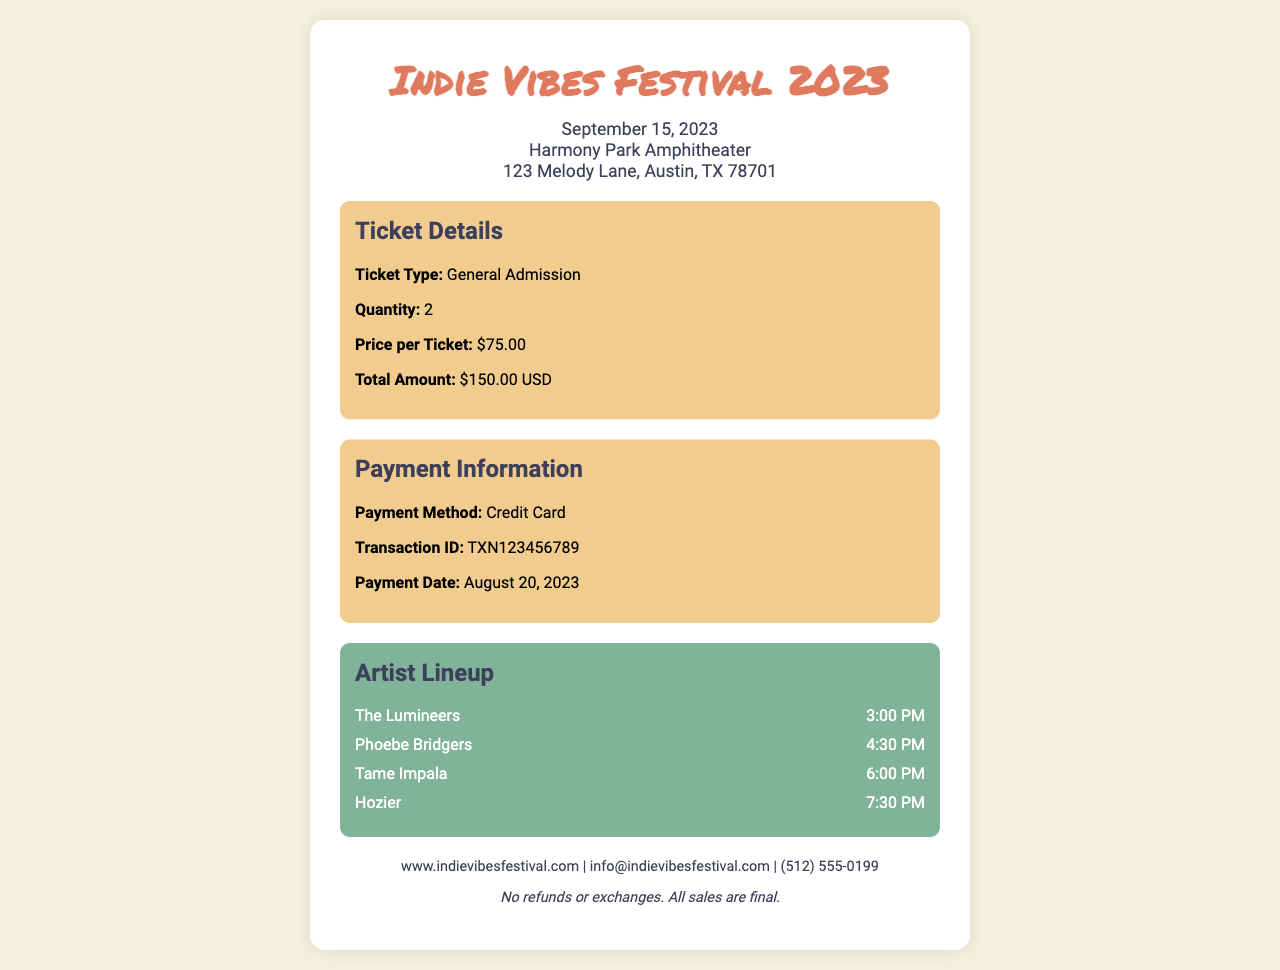What is the name of the festival? The name of the festival is prominently displayed at the top of the receipt.
Answer: Indie Vibes Festival 2023 When is the festival date? The festival date is mentioned in the date-venue section of the receipt.
Answer: September 15, 2023 Where is the venue located? The venue location is provided in the same date-venue section as the festival date.
Answer: Harmony Park Amphitheater What is the ticket type purchased? The ticket type is specified in the ticket details section of the receipt.
Answer: General Admission How many tickets were purchased? The quantity of tickets is mentioned in the ticket details section.
Answer: 2 What is the price per ticket? The price per ticket is detailed in the ticket details section.
Answer: $75.00 What is the total amount paid? The total amount is indicated in the ticket details section of the document.
Answer: $150.00 USD What is the transaction ID? The transaction ID is found in the payment information section.
Answer: TXN123456789 Which artist performs at 6:00 PM? The artist performing at this specific time is listed in the artist lineup section.
Answer: Tame Impala What is the payment method used? The payment method is provided in the payment information section of the receipt.
Answer: Credit Card 